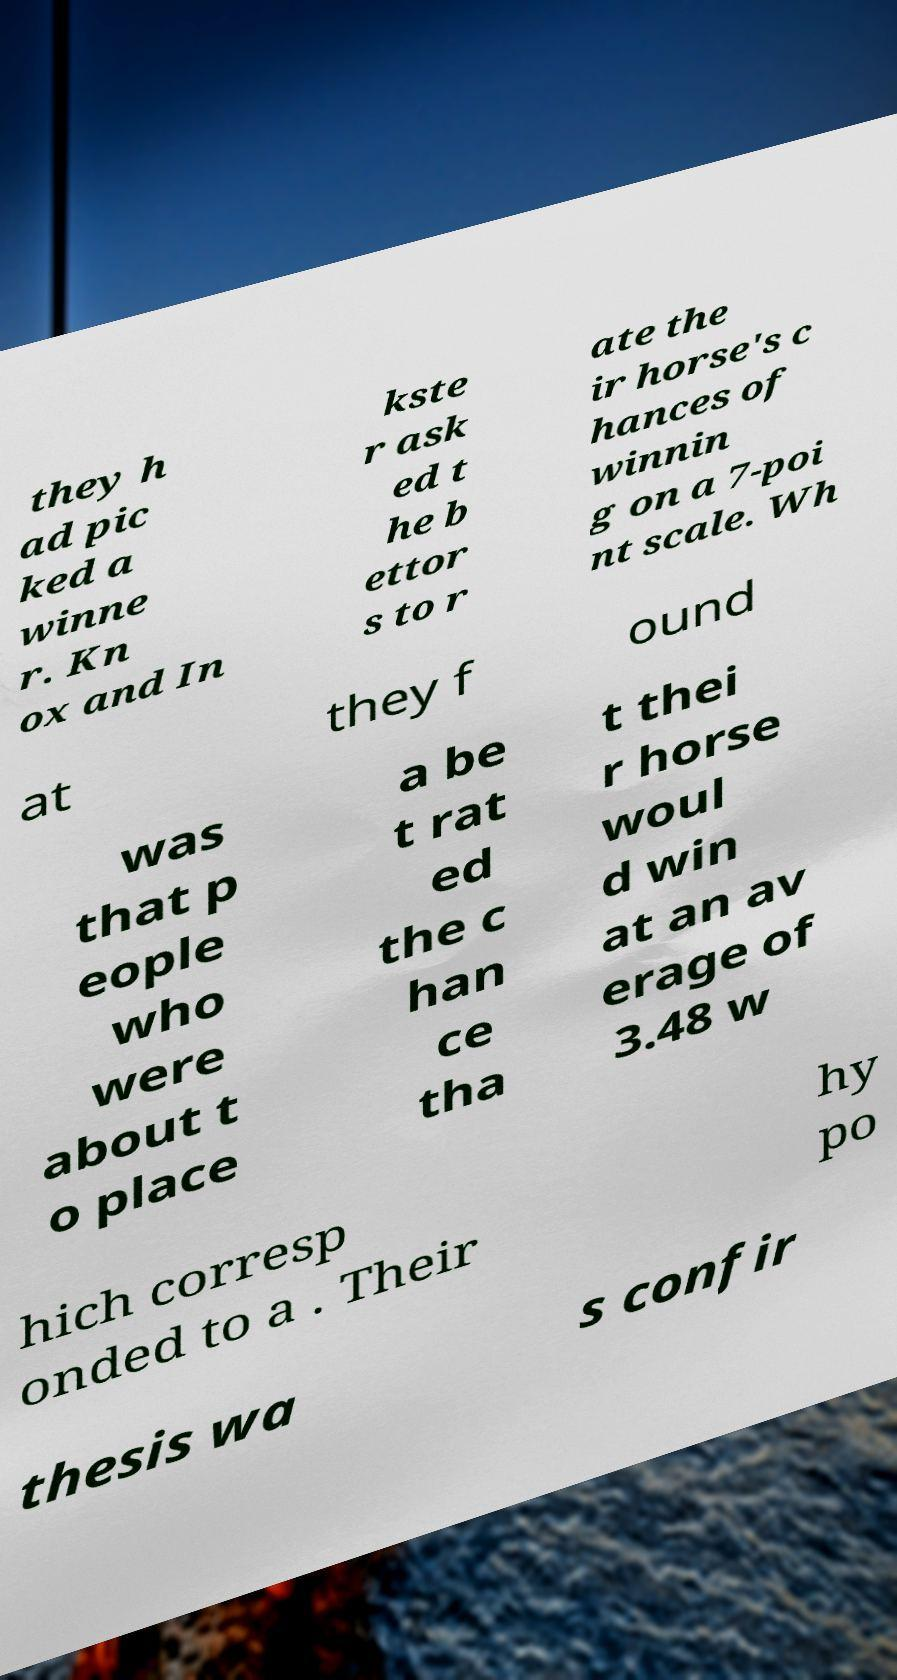Can you read and provide the text displayed in the image?This photo seems to have some interesting text. Can you extract and type it out for me? they h ad pic ked a winne r. Kn ox and In kste r ask ed t he b ettor s to r ate the ir horse's c hances of winnin g on a 7-poi nt scale. Wh at they f ound was that p eople who were about t o place a be t rat ed the c han ce tha t thei r horse woul d win at an av erage of 3.48 w hich corresp onded to a . Their hy po thesis wa s confir 